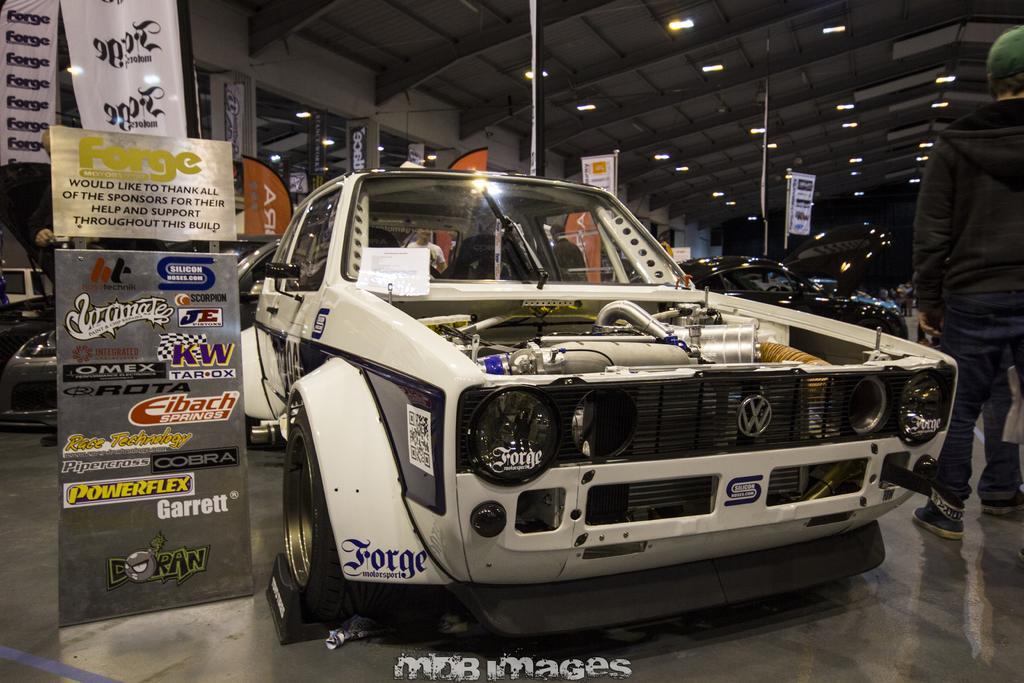Describe this image in one or two sentences. In this picture, we can see vehicles are parked on the path and some people are standing and on the left side of the car there is a board and banner and on the top there are lights. 